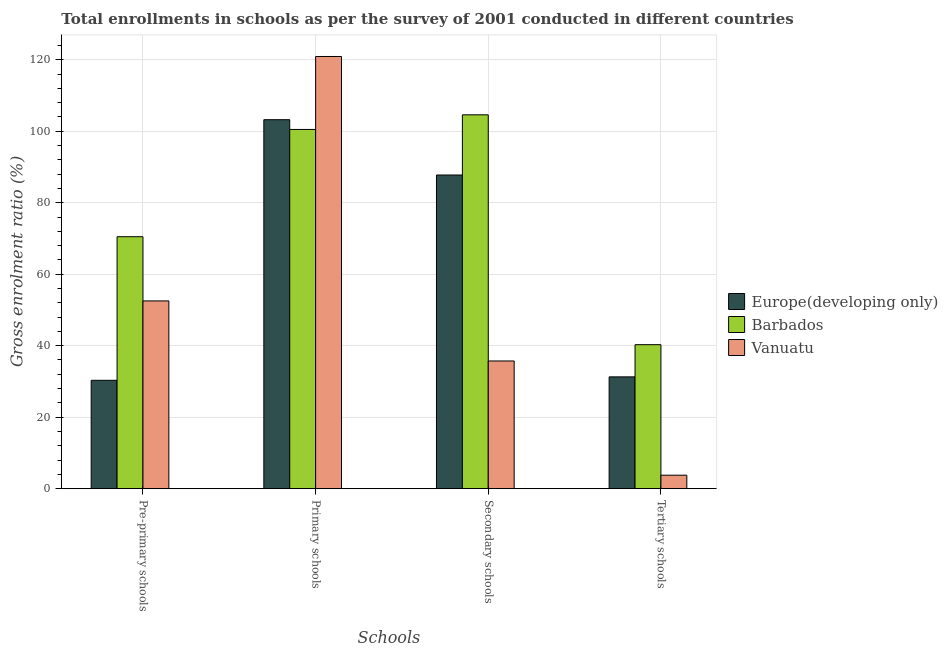How many groups of bars are there?
Ensure brevity in your answer.  4. Are the number of bars per tick equal to the number of legend labels?
Offer a very short reply. Yes. Are the number of bars on each tick of the X-axis equal?
Offer a terse response. Yes. How many bars are there on the 2nd tick from the right?
Your answer should be compact. 3. What is the label of the 4th group of bars from the left?
Offer a terse response. Tertiary schools. What is the gross enrolment ratio in primary schools in Europe(developing only)?
Provide a short and direct response. 103.23. Across all countries, what is the maximum gross enrolment ratio in tertiary schools?
Offer a very short reply. 40.28. Across all countries, what is the minimum gross enrolment ratio in secondary schools?
Offer a very short reply. 35.73. In which country was the gross enrolment ratio in primary schools maximum?
Your answer should be very brief. Vanuatu. In which country was the gross enrolment ratio in pre-primary schools minimum?
Your answer should be very brief. Europe(developing only). What is the total gross enrolment ratio in tertiary schools in the graph?
Your answer should be very brief. 75.33. What is the difference between the gross enrolment ratio in primary schools in Europe(developing only) and that in Vanuatu?
Ensure brevity in your answer.  -17.68. What is the difference between the gross enrolment ratio in secondary schools in Barbados and the gross enrolment ratio in tertiary schools in Europe(developing only)?
Your answer should be compact. 73.31. What is the average gross enrolment ratio in pre-primary schools per country?
Provide a succinct answer. 51.11. What is the difference between the gross enrolment ratio in pre-primary schools and gross enrolment ratio in primary schools in Barbados?
Your response must be concise. -30.01. What is the ratio of the gross enrolment ratio in pre-primary schools in Vanuatu to that in Europe(developing only)?
Your response must be concise. 1.73. What is the difference between the highest and the second highest gross enrolment ratio in tertiary schools?
Ensure brevity in your answer.  9.01. What is the difference between the highest and the lowest gross enrolment ratio in tertiary schools?
Give a very brief answer. 36.51. In how many countries, is the gross enrolment ratio in pre-primary schools greater than the average gross enrolment ratio in pre-primary schools taken over all countries?
Give a very brief answer. 2. Is the sum of the gross enrolment ratio in primary schools in Europe(developing only) and Barbados greater than the maximum gross enrolment ratio in pre-primary schools across all countries?
Offer a very short reply. Yes. Is it the case that in every country, the sum of the gross enrolment ratio in primary schools and gross enrolment ratio in tertiary schools is greater than the sum of gross enrolment ratio in pre-primary schools and gross enrolment ratio in secondary schools?
Your answer should be compact. Yes. What does the 1st bar from the left in Tertiary schools represents?
Provide a short and direct response. Europe(developing only). What does the 1st bar from the right in Tertiary schools represents?
Make the answer very short. Vanuatu. How many bars are there?
Keep it short and to the point. 12. What is the difference between two consecutive major ticks on the Y-axis?
Ensure brevity in your answer.  20. Are the values on the major ticks of Y-axis written in scientific E-notation?
Offer a very short reply. No. Does the graph contain any zero values?
Give a very brief answer. No. What is the title of the graph?
Your answer should be very brief. Total enrollments in schools as per the survey of 2001 conducted in different countries. What is the label or title of the X-axis?
Offer a very short reply. Schools. What is the label or title of the Y-axis?
Give a very brief answer. Gross enrolment ratio (%). What is the Gross enrolment ratio (%) of Europe(developing only) in Pre-primary schools?
Give a very brief answer. 30.32. What is the Gross enrolment ratio (%) in Barbados in Pre-primary schools?
Keep it short and to the point. 70.49. What is the Gross enrolment ratio (%) in Vanuatu in Pre-primary schools?
Your response must be concise. 52.53. What is the Gross enrolment ratio (%) of Europe(developing only) in Primary schools?
Your answer should be compact. 103.23. What is the Gross enrolment ratio (%) of Barbados in Primary schools?
Offer a very short reply. 100.5. What is the Gross enrolment ratio (%) in Vanuatu in Primary schools?
Your answer should be very brief. 120.91. What is the Gross enrolment ratio (%) of Europe(developing only) in Secondary schools?
Your response must be concise. 87.75. What is the Gross enrolment ratio (%) of Barbados in Secondary schools?
Provide a short and direct response. 104.59. What is the Gross enrolment ratio (%) of Vanuatu in Secondary schools?
Your answer should be compact. 35.73. What is the Gross enrolment ratio (%) of Europe(developing only) in Tertiary schools?
Your answer should be very brief. 31.28. What is the Gross enrolment ratio (%) in Barbados in Tertiary schools?
Your answer should be very brief. 40.28. What is the Gross enrolment ratio (%) of Vanuatu in Tertiary schools?
Your answer should be very brief. 3.77. Across all Schools, what is the maximum Gross enrolment ratio (%) of Europe(developing only)?
Offer a terse response. 103.23. Across all Schools, what is the maximum Gross enrolment ratio (%) of Barbados?
Your response must be concise. 104.59. Across all Schools, what is the maximum Gross enrolment ratio (%) in Vanuatu?
Your response must be concise. 120.91. Across all Schools, what is the minimum Gross enrolment ratio (%) in Europe(developing only)?
Keep it short and to the point. 30.32. Across all Schools, what is the minimum Gross enrolment ratio (%) in Barbados?
Make the answer very short. 40.28. Across all Schools, what is the minimum Gross enrolment ratio (%) in Vanuatu?
Provide a short and direct response. 3.77. What is the total Gross enrolment ratio (%) of Europe(developing only) in the graph?
Ensure brevity in your answer.  252.57. What is the total Gross enrolment ratio (%) of Barbados in the graph?
Offer a very short reply. 315.86. What is the total Gross enrolment ratio (%) in Vanuatu in the graph?
Give a very brief answer. 212.93. What is the difference between the Gross enrolment ratio (%) of Europe(developing only) in Pre-primary schools and that in Primary schools?
Provide a succinct answer. -72.91. What is the difference between the Gross enrolment ratio (%) in Barbados in Pre-primary schools and that in Primary schools?
Make the answer very short. -30.01. What is the difference between the Gross enrolment ratio (%) in Vanuatu in Pre-primary schools and that in Primary schools?
Your answer should be very brief. -68.38. What is the difference between the Gross enrolment ratio (%) in Europe(developing only) in Pre-primary schools and that in Secondary schools?
Offer a terse response. -57.43. What is the difference between the Gross enrolment ratio (%) of Barbados in Pre-primary schools and that in Secondary schools?
Offer a very short reply. -34.1. What is the difference between the Gross enrolment ratio (%) in Vanuatu in Pre-primary schools and that in Secondary schools?
Offer a very short reply. 16.8. What is the difference between the Gross enrolment ratio (%) in Europe(developing only) in Pre-primary schools and that in Tertiary schools?
Ensure brevity in your answer.  -0.96. What is the difference between the Gross enrolment ratio (%) of Barbados in Pre-primary schools and that in Tertiary schools?
Give a very brief answer. 30.2. What is the difference between the Gross enrolment ratio (%) of Vanuatu in Pre-primary schools and that in Tertiary schools?
Ensure brevity in your answer.  48.75. What is the difference between the Gross enrolment ratio (%) in Europe(developing only) in Primary schools and that in Secondary schools?
Your response must be concise. 15.48. What is the difference between the Gross enrolment ratio (%) of Barbados in Primary schools and that in Secondary schools?
Keep it short and to the point. -4.09. What is the difference between the Gross enrolment ratio (%) in Vanuatu in Primary schools and that in Secondary schools?
Provide a succinct answer. 85.18. What is the difference between the Gross enrolment ratio (%) of Europe(developing only) in Primary schools and that in Tertiary schools?
Your answer should be very brief. 71.95. What is the difference between the Gross enrolment ratio (%) in Barbados in Primary schools and that in Tertiary schools?
Your answer should be compact. 60.21. What is the difference between the Gross enrolment ratio (%) of Vanuatu in Primary schools and that in Tertiary schools?
Your answer should be very brief. 117.14. What is the difference between the Gross enrolment ratio (%) of Europe(developing only) in Secondary schools and that in Tertiary schools?
Ensure brevity in your answer.  56.47. What is the difference between the Gross enrolment ratio (%) in Barbados in Secondary schools and that in Tertiary schools?
Offer a very short reply. 64.31. What is the difference between the Gross enrolment ratio (%) of Vanuatu in Secondary schools and that in Tertiary schools?
Ensure brevity in your answer.  31.95. What is the difference between the Gross enrolment ratio (%) of Europe(developing only) in Pre-primary schools and the Gross enrolment ratio (%) of Barbados in Primary schools?
Your answer should be very brief. -70.18. What is the difference between the Gross enrolment ratio (%) of Europe(developing only) in Pre-primary schools and the Gross enrolment ratio (%) of Vanuatu in Primary schools?
Your response must be concise. -90.59. What is the difference between the Gross enrolment ratio (%) of Barbados in Pre-primary schools and the Gross enrolment ratio (%) of Vanuatu in Primary schools?
Provide a succinct answer. -50.42. What is the difference between the Gross enrolment ratio (%) in Europe(developing only) in Pre-primary schools and the Gross enrolment ratio (%) in Barbados in Secondary schools?
Provide a succinct answer. -74.27. What is the difference between the Gross enrolment ratio (%) in Europe(developing only) in Pre-primary schools and the Gross enrolment ratio (%) in Vanuatu in Secondary schools?
Offer a terse response. -5.41. What is the difference between the Gross enrolment ratio (%) of Barbados in Pre-primary schools and the Gross enrolment ratio (%) of Vanuatu in Secondary schools?
Your response must be concise. 34.76. What is the difference between the Gross enrolment ratio (%) in Europe(developing only) in Pre-primary schools and the Gross enrolment ratio (%) in Barbados in Tertiary schools?
Keep it short and to the point. -9.97. What is the difference between the Gross enrolment ratio (%) of Europe(developing only) in Pre-primary schools and the Gross enrolment ratio (%) of Vanuatu in Tertiary schools?
Your answer should be very brief. 26.54. What is the difference between the Gross enrolment ratio (%) of Barbados in Pre-primary schools and the Gross enrolment ratio (%) of Vanuatu in Tertiary schools?
Your response must be concise. 66.71. What is the difference between the Gross enrolment ratio (%) of Europe(developing only) in Primary schools and the Gross enrolment ratio (%) of Barbados in Secondary schools?
Keep it short and to the point. -1.36. What is the difference between the Gross enrolment ratio (%) of Europe(developing only) in Primary schools and the Gross enrolment ratio (%) of Vanuatu in Secondary schools?
Offer a very short reply. 67.5. What is the difference between the Gross enrolment ratio (%) in Barbados in Primary schools and the Gross enrolment ratio (%) in Vanuatu in Secondary schools?
Your response must be concise. 64.77. What is the difference between the Gross enrolment ratio (%) of Europe(developing only) in Primary schools and the Gross enrolment ratio (%) of Barbados in Tertiary schools?
Provide a succinct answer. 62.94. What is the difference between the Gross enrolment ratio (%) of Europe(developing only) in Primary schools and the Gross enrolment ratio (%) of Vanuatu in Tertiary schools?
Keep it short and to the point. 99.45. What is the difference between the Gross enrolment ratio (%) in Barbados in Primary schools and the Gross enrolment ratio (%) in Vanuatu in Tertiary schools?
Make the answer very short. 96.72. What is the difference between the Gross enrolment ratio (%) of Europe(developing only) in Secondary schools and the Gross enrolment ratio (%) of Barbados in Tertiary schools?
Give a very brief answer. 47.47. What is the difference between the Gross enrolment ratio (%) of Europe(developing only) in Secondary schools and the Gross enrolment ratio (%) of Vanuatu in Tertiary schools?
Offer a terse response. 83.98. What is the difference between the Gross enrolment ratio (%) of Barbados in Secondary schools and the Gross enrolment ratio (%) of Vanuatu in Tertiary schools?
Your answer should be compact. 100.82. What is the average Gross enrolment ratio (%) of Europe(developing only) per Schools?
Ensure brevity in your answer.  63.14. What is the average Gross enrolment ratio (%) of Barbados per Schools?
Give a very brief answer. 78.97. What is the average Gross enrolment ratio (%) in Vanuatu per Schools?
Keep it short and to the point. 53.23. What is the difference between the Gross enrolment ratio (%) of Europe(developing only) and Gross enrolment ratio (%) of Barbados in Pre-primary schools?
Provide a succinct answer. -40.17. What is the difference between the Gross enrolment ratio (%) in Europe(developing only) and Gross enrolment ratio (%) in Vanuatu in Pre-primary schools?
Your response must be concise. -22.21. What is the difference between the Gross enrolment ratio (%) of Barbados and Gross enrolment ratio (%) of Vanuatu in Pre-primary schools?
Keep it short and to the point. 17.96. What is the difference between the Gross enrolment ratio (%) in Europe(developing only) and Gross enrolment ratio (%) in Barbados in Primary schools?
Ensure brevity in your answer.  2.73. What is the difference between the Gross enrolment ratio (%) in Europe(developing only) and Gross enrolment ratio (%) in Vanuatu in Primary schools?
Your answer should be very brief. -17.68. What is the difference between the Gross enrolment ratio (%) in Barbados and Gross enrolment ratio (%) in Vanuatu in Primary schools?
Offer a very short reply. -20.41. What is the difference between the Gross enrolment ratio (%) of Europe(developing only) and Gross enrolment ratio (%) of Barbados in Secondary schools?
Provide a short and direct response. -16.84. What is the difference between the Gross enrolment ratio (%) in Europe(developing only) and Gross enrolment ratio (%) in Vanuatu in Secondary schools?
Provide a succinct answer. 52.03. What is the difference between the Gross enrolment ratio (%) in Barbados and Gross enrolment ratio (%) in Vanuatu in Secondary schools?
Give a very brief answer. 68.87. What is the difference between the Gross enrolment ratio (%) of Europe(developing only) and Gross enrolment ratio (%) of Barbados in Tertiary schools?
Your response must be concise. -9.01. What is the difference between the Gross enrolment ratio (%) in Europe(developing only) and Gross enrolment ratio (%) in Vanuatu in Tertiary schools?
Offer a terse response. 27.5. What is the difference between the Gross enrolment ratio (%) in Barbados and Gross enrolment ratio (%) in Vanuatu in Tertiary schools?
Your answer should be very brief. 36.51. What is the ratio of the Gross enrolment ratio (%) in Europe(developing only) in Pre-primary schools to that in Primary schools?
Offer a terse response. 0.29. What is the ratio of the Gross enrolment ratio (%) of Barbados in Pre-primary schools to that in Primary schools?
Your answer should be compact. 0.7. What is the ratio of the Gross enrolment ratio (%) in Vanuatu in Pre-primary schools to that in Primary schools?
Your answer should be compact. 0.43. What is the ratio of the Gross enrolment ratio (%) in Europe(developing only) in Pre-primary schools to that in Secondary schools?
Provide a succinct answer. 0.35. What is the ratio of the Gross enrolment ratio (%) of Barbados in Pre-primary schools to that in Secondary schools?
Give a very brief answer. 0.67. What is the ratio of the Gross enrolment ratio (%) of Vanuatu in Pre-primary schools to that in Secondary schools?
Offer a terse response. 1.47. What is the ratio of the Gross enrolment ratio (%) in Europe(developing only) in Pre-primary schools to that in Tertiary schools?
Provide a succinct answer. 0.97. What is the ratio of the Gross enrolment ratio (%) in Barbados in Pre-primary schools to that in Tertiary schools?
Your answer should be very brief. 1.75. What is the ratio of the Gross enrolment ratio (%) in Vanuatu in Pre-primary schools to that in Tertiary schools?
Ensure brevity in your answer.  13.92. What is the ratio of the Gross enrolment ratio (%) in Europe(developing only) in Primary schools to that in Secondary schools?
Provide a succinct answer. 1.18. What is the ratio of the Gross enrolment ratio (%) of Barbados in Primary schools to that in Secondary schools?
Provide a short and direct response. 0.96. What is the ratio of the Gross enrolment ratio (%) in Vanuatu in Primary schools to that in Secondary schools?
Provide a succinct answer. 3.38. What is the ratio of the Gross enrolment ratio (%) of Europe(developing only) in Primary schools to that in Tertiary schools?
Provide a short and direct response. 3.3. What is the ratio of the Gross enrolment ratio (%) of Barbados in Primary schools to that in Tertiary schools?
Provide a short and direct response. 2.49. What is the ratio of the Gross enrolment ratio (%) of Vanuatu in Primary schools to that in Tertiary schools?
Make the answer very short. 32.04. What is the ratio of the Gross enrolment ratio (%) in Europe(developing only) in Secondary schools to that in Tertiary schools?
Your response must be concise. 2.81. What is the ratio of the Gross enrolment ratio (%) in Barbados in Secondary schools to that in Tertiary schools?
Provide a succinct answer. 2.6. What is the ratio of the Gross enrolment ratio (%) in Vanuatu in Secondary schools to that in Tertiary schools?
Your answer should be compact. 9.47. What is the difference between the highest and the second highest Gross enrolment ratio (%) of Europe(developing only)?
Keep it short and to the point. 15.48. What is the difference between the highest and the second highest Gross enrolment ratio (%) of Barbados?
Offer a terse response. 4.09. What is the difference between the highest and the second highest Gross enrolment ratio (%) in Vanuatu?
Give a very brief answer. 68.38. What is the difference between the highest and the lowest Gross enrolment ratio (%) of Europe(developing only)?
Your answer should be compact. 72.91. What is the difference between the highest and the lowest Gross enrolment ratio (%) in Barbados?
Offer a terse response. 64.31. What is the difference between the highest and the lowest Gross enrolment ratio (%) of Vanuatu?
Provide a succinct answer. 117.14. 